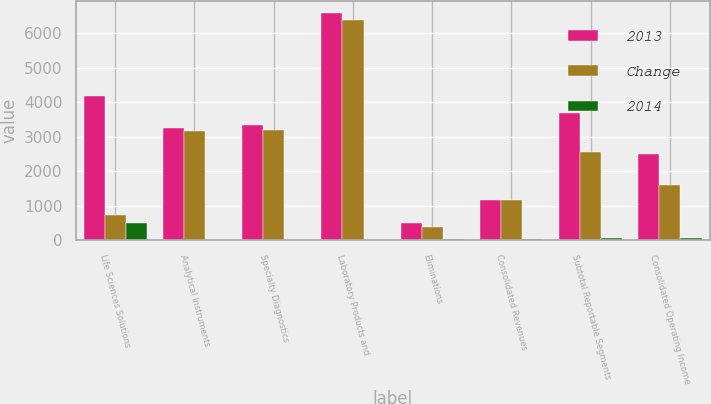<chart> <loc_0><loc_0><loc_500><loc_500><stacked_bar_chart><ecel><fcel>Life Sciences Solutions<fcel>Analytical Instruments<fcel>Specialty Diagnostics<fcel>Laboratory Products and<fcel>Eliminations<fcel>Consolidated Revenues<fcel>Subtotal Reportable Segments<fcel>Consolidated Operating Income<nl><fcel>2013<fcel>4195.7<fcel>3252.2<fcel>3343.6<fcel>6601.5<fcel>503.4<fcel>1161.05<fcel>3694.8<fcel>2503<nl><fcel>Change<fcel>712.5<fcel>3154.2<fcel>3191.7<fcel>6398.8<fcel>366.9<fcel>1161.05<fcel>2552.5<fcel>1609.6<nl><fcel>2014<fcel>489<fcel>3<fcel>5<fcel>3<fcel>37<fcel>29<fcel>45<fcel>56<nl></chart> 